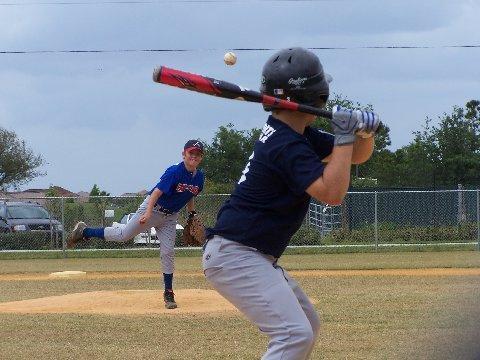How many people can be seen?
Give a very brief answer. 2. How many white trucks can you see?
Give a very brief answer. 0. 